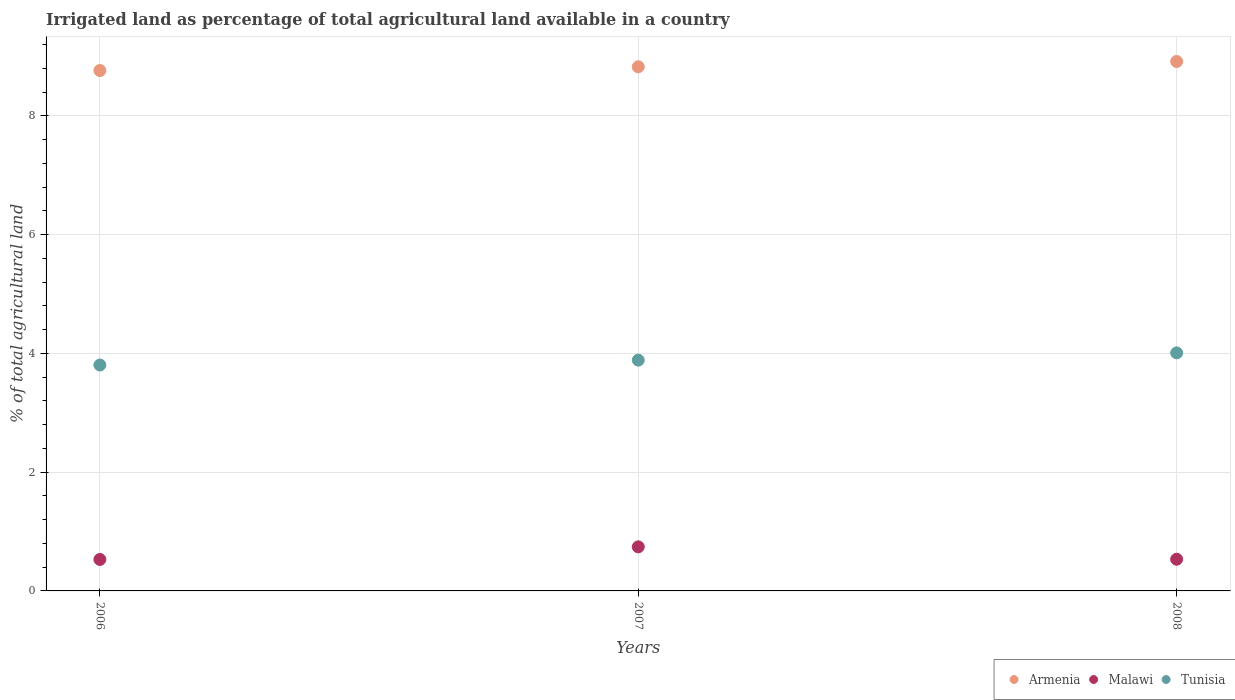How many different coloured dotlines are there?
Make the answer very short. 3. Is the number of dotlines equal to the number of legend labels?
Keep it short and to the point. Yes. What is the percentage of irrigated land in Malawi in 2008?
Ensure brevity in your answer.  0.53. Across all years, what is the maximum percentage of irrigated land in Malawi?
Offer a terse response. 0.74. Across all years, what is the minimum percentage of irrigated land in Malawi?
Provide a short and direct response. 0.53. What is the total percentage of irrigated land in Tunisia in the graph?
Keep it short and to the point. 11.7. What is the difference between the percentage of irrigated land in Tunisia in 2007 and that in 2008?
Give a very brief answer. -0.12. What is the difference between the percentage of irrigated land in Armenia in 2006 and the percentage of irrigated land in Malawi in 2008?
Keep it short and to the point. 8.23. What is the average percentage of irrigated land in Armenia per year?
Provide a succinct answer. 8.83. In the year 2006, what is the difference between the percentage of irrigated land in Armenia and percentage of irrigated land in Tunisia?
Keep it short and to the point. 4.96. What is the ratio of the percentage of irrigated land in Malawi in 2006 to that in 2008?
Make the answer very short. 0.99. What is the difference between the highest and the second highest percentage of irrigated land in Malawi?
Provide a short and direct response. 0.21. What is the difference between the highest and the lowest percentage of irrigated land in Tunisia?
Your answer should be very brief. 0.2. In how many years, is the percentage of irrigated land in Armenia greater than the average percentage of irrigated land in Armenia taken over all years?
Your answer should be compact. 1. Is the sum of the percentage of irrigated land in Tunisia in 2006 and 2008 greater than the maximum percentage of irrigated land in Malawi across all years?
Give a very brief answer. Yes. Is the percentage of irrigated land in Malawi strictly less than the percentage of irrigated land in Tunisia over the years?
Make the answer very short. Yes. How many years are there in the graph?
Give a very brief answer. 3. What is the difference between two consecutive major ticks on the Y-axis?
Your answer should be compact. 2. Are the values on the major ticks of Y-axis written in scientific E-notation?
Ensure brevity in your answer.  No. Where does the legend appear in the graph?
Your answer should be very brief. Bottom right. How are the legend labels stacked?
Your answer should be very brief. Horizontal. What is the title of the graph?
Provide a short and direct response. Irrigated land as percentage of total agricultural land available in a country. What is the label or title of the Y-axis?
Your response must be concise. % of total agricultural land. What is the % of total agricultural land in Armenia in 2006?
Make the answer very short. 8.76. What is the % of total agricultural land of Malawi in 2006?
Provide a short and direct response. 0.53. What is the % of total agricultural land of Tunisia in 2006?
Your answer should be very brief. 3.8. What is the % of total agricultural land of Armenia in 2007?
Offer a very short reply. 8.82. What is the % of total agricultural land in Malawi in 2007?
Provide a short and direct response. 0.74. What is the % of total agricultural land in Tunisia in 2007?
Provide a succinct answer. 3.89. What is the % of total agricultural land in Armenia in 2008?
Give a very brief answer. 8.91. What is the % of total agricultural land in Malawi in 2008?
Provide a short and direct response. 0.53. What is the % of total agricultural land in Tunisia in 2008?
Your response must be concise. 4.01. Across all years, what is the maximum % of total agricultural land in Armenia?
Your answer should be compact. 8.91. Across all years, what is the maximum % of total agricultural land of Malawi?
Ensure brevity in your answer.  0.74. Across all years, what is the maximum % of total agricultural land of Tunisia?
Make the answer very short. 4.01. Across all years, what is the minimum % of total agricultural land of Armenia?
Give a very brief answer. 8.76. Across all years, what is the minimum % of total agricultural land of Malawi?
Make the answer very short. 0.53. Across all years, what is the minimum % of total agricultural land of Tunisia?
Offer a very short reply. 3.8. What is the total % of total agricultural land in Armenia in the graph?
Provide a succinct answer. 26.5. What is the total % of total agricultural land in Malawi in the graph?
Offer a very short reply. 1.81. What is the total % of total agricultural land of Tunisia in the graph?
Offer a very short reply. 11.7. What is the difference between the % of total agricultural land of Armenia in 2006 and that in 2007?
Give a very brief answer. -0.06. What is the difference between the % of total agricultural land of Malawi in 2006 and that in 2007?
Keep it short and to the point. -0.21. What is the difference between the % of total agricultural land in Tunisia in 2006 and that in 2007?
Make the answer very short. -0.08. What is the difference between the % of total agricultural land in Armenia in 2006 and that in 2008?
Provide a short and direct response. -0.15. What is the difference between the % of total agricultural land of Malawi in 2006 and that in 2008?
Provide a short and direct response. -0. What is the difference between the % of total agricultural land of Tunisia in 2006 and that in 2008?
Provide a short and direct response. -0.2. What is the difference between the % of total agricultural land in Armenia in 2007 and that in 2008?
Offer a terse response. -0.09. What is the difference between the % of total agricultural land in Malawi in 2007 and that in 2008?
Offer a terse response. 0.21. What is the difference between the % of total agricultural land in Tunisia in 2007 and that in 2008?
Your response must be concise. -0.12. What is the difference between the % of total agricultural land of Armenia in 2006 and the % of total agricultural land of Malawi in 2007?
Your answer should be very brief. 8.02. What is the difference between the % of total agricultural land in Armenia in 2006 and the % of total agricultural land in Tunisia in 2007?
Ensure brevity in your answer.  4.88. What is the difference between the % of total agricultural land of Malawi in 2006 and the % of total agricultural land of Tunisia in 2007?
Offer a very short reply. -3.36. What is the difference between the % of total agricultural land of Armenia in 2006 and the % of total agricultural land of Malawi in 2008?
Provide a succinct answer. 8.23. What is the difference between the % of total agricultural land of Armenia in 2006 and the % of total agricultural land of Tunisia in 2008?
Offer a very short reply. 4.75. What is the difference between the % of total agricultural land in Malawi in 2006 and the % of total agricultural land in Tunisia in 2008?
Provide a succinct answer. -3.48. What is the difference between the % of total agricultural land in Armenia in 2007 and the % of total agricultural land in Malawi in 2008?
Your answer should be compact. 8.29. What is the difference between the % of total agricultural land of Armenia in 2007 and the % of total agricultural land of Tunisia in 2008?
Ensure brevity in your answer.  4.82. What is the difference between the % of total agricultural land in Malawi in 2007 and the % of total agricultural land in Tunisia in 2008?
Give a very brief answer. -3.27. What is the average % of total agricultural land of Armenia per year?
Your answer should be compact. 8.83. What is the average % of total agricultural land of Malawi per year?
Keep it short and to the point. 0.6. What is the average % of total agricultural land of Tunisia per year?
Keep it short and to the point. 3.9. In the year 2006, what is the difference between the % of total agricultural land of Armenia and % of total agricultural land of Malawi?
Provide a short and direct response. 8.23. In the year 2006, what is the difference between the % of total agricultural land in Armenia and % of total agricultural land in Tunisia?
Offer a terse response. 4.96. In the year 2006, what is the difference between the % of total agricultural land in Malawi and % of total agricultural land in Tunisia?
Your response must be concise. -3.27. In the year 2007, what is the difference between the % of total agricultural land of Armenia and % of total agricultural land of Malawi?
Your response must be concise. 8.08. In the year 2007, what is the difference between the % of total agricultural land of Armenia and % of total agricultural land of Tunisia?
Your response must be concise. 4.94. In the year 2007, what is the difference between the % of total agricultural land in Malawi and % of total agricultural land in Tunisia?
Provide a succinct answer. -3.14. In the year 2008, what is the difference between the % of total agricultural land in Armenia and % of total agricultural land in Malawi?
Your response must be concise. 8.38. In the year 2008, what is the difference between the % of total agricultural land of Armenia and % of total agricultural land of Tunisia?
Your answer should be very brief. 4.91. In the year 2008, what is the difference between the % of total agricultural land of Malawi and % of total agricultural land of Tunisia?
Offer a terse response. -3.47. What is the ratio of the % of total agricultural land in Armenia in 2006 to that in 2007?
Provide a succinct answer. 0.99. What is the ratio of the % of total agricultural land of Malawi in 2006 to that in 2007?
Offer a very short reply. 0.71. What is the ratio of the % of total agricultural land in Tunisia in 2006 to that in 2007?
Your response must be concise. 0.98. What is the ratio of the % of total agricultural land in Armenia in 2006 to that in 2008?
Ensure brevity in your answer.  0.98. What is the ratio of the % of total agricultural land of Tunisia in 2006 to that in 2008?
Provide a succinct answer. 0.95. What is the ratio of the % of total agricultural land of Armenia in 2007 to that in 2008?
Keep it short and to the point. 0.99. What is the ratio of the % of total agricultural land in Malawi in 2007 to that in 2008?
Give a very brief answer. 1.39. What is the ratio of the % of total agricultural land of Tunisia in 2007 to that in 2008?
Provide a short and direct response. 0.97. What is the difference between the highest and the second highest % of total agricultural land in Armenia?
Offer a very short reply. 0.09. What is the difference between the highest and the second highest % of total agricultural land in Malawi?
Offer a very short reply. 0.21. What is the difference between the highest and the second highest % of total agricultural land of Tunisia?
Your answer should be very brief. 0.12. What is the difference between the highest and the lowest % of total agricultural land of Armenia?
Ensure brevity in your answer.  0.15. What is the difference between the highest and the lowest % of total agricultural land of Malawi?
Your response must be concise. 0.21. What is the difference between the highest and the lowest % of total agricultural land in Tunisia?
Make the answer very short. 0.2. 